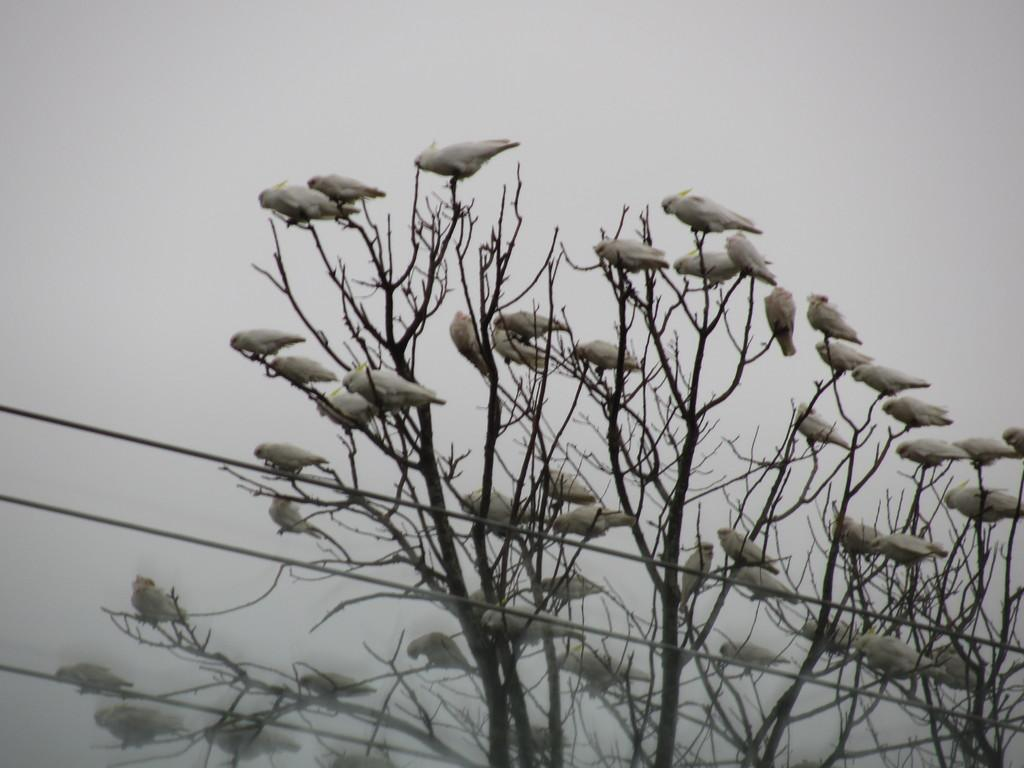What type of animals can be seen in the image? There are birds on the trees in the image. What is located at the bottom of the image? There are wires at the bottom of the image. What can be seen in the background of the image? The sky is visible in the background of the image. What language are the birds speaking in the image? Birds do not speak human languages, so it is not possible to determine what language they might be speaking in the image. 